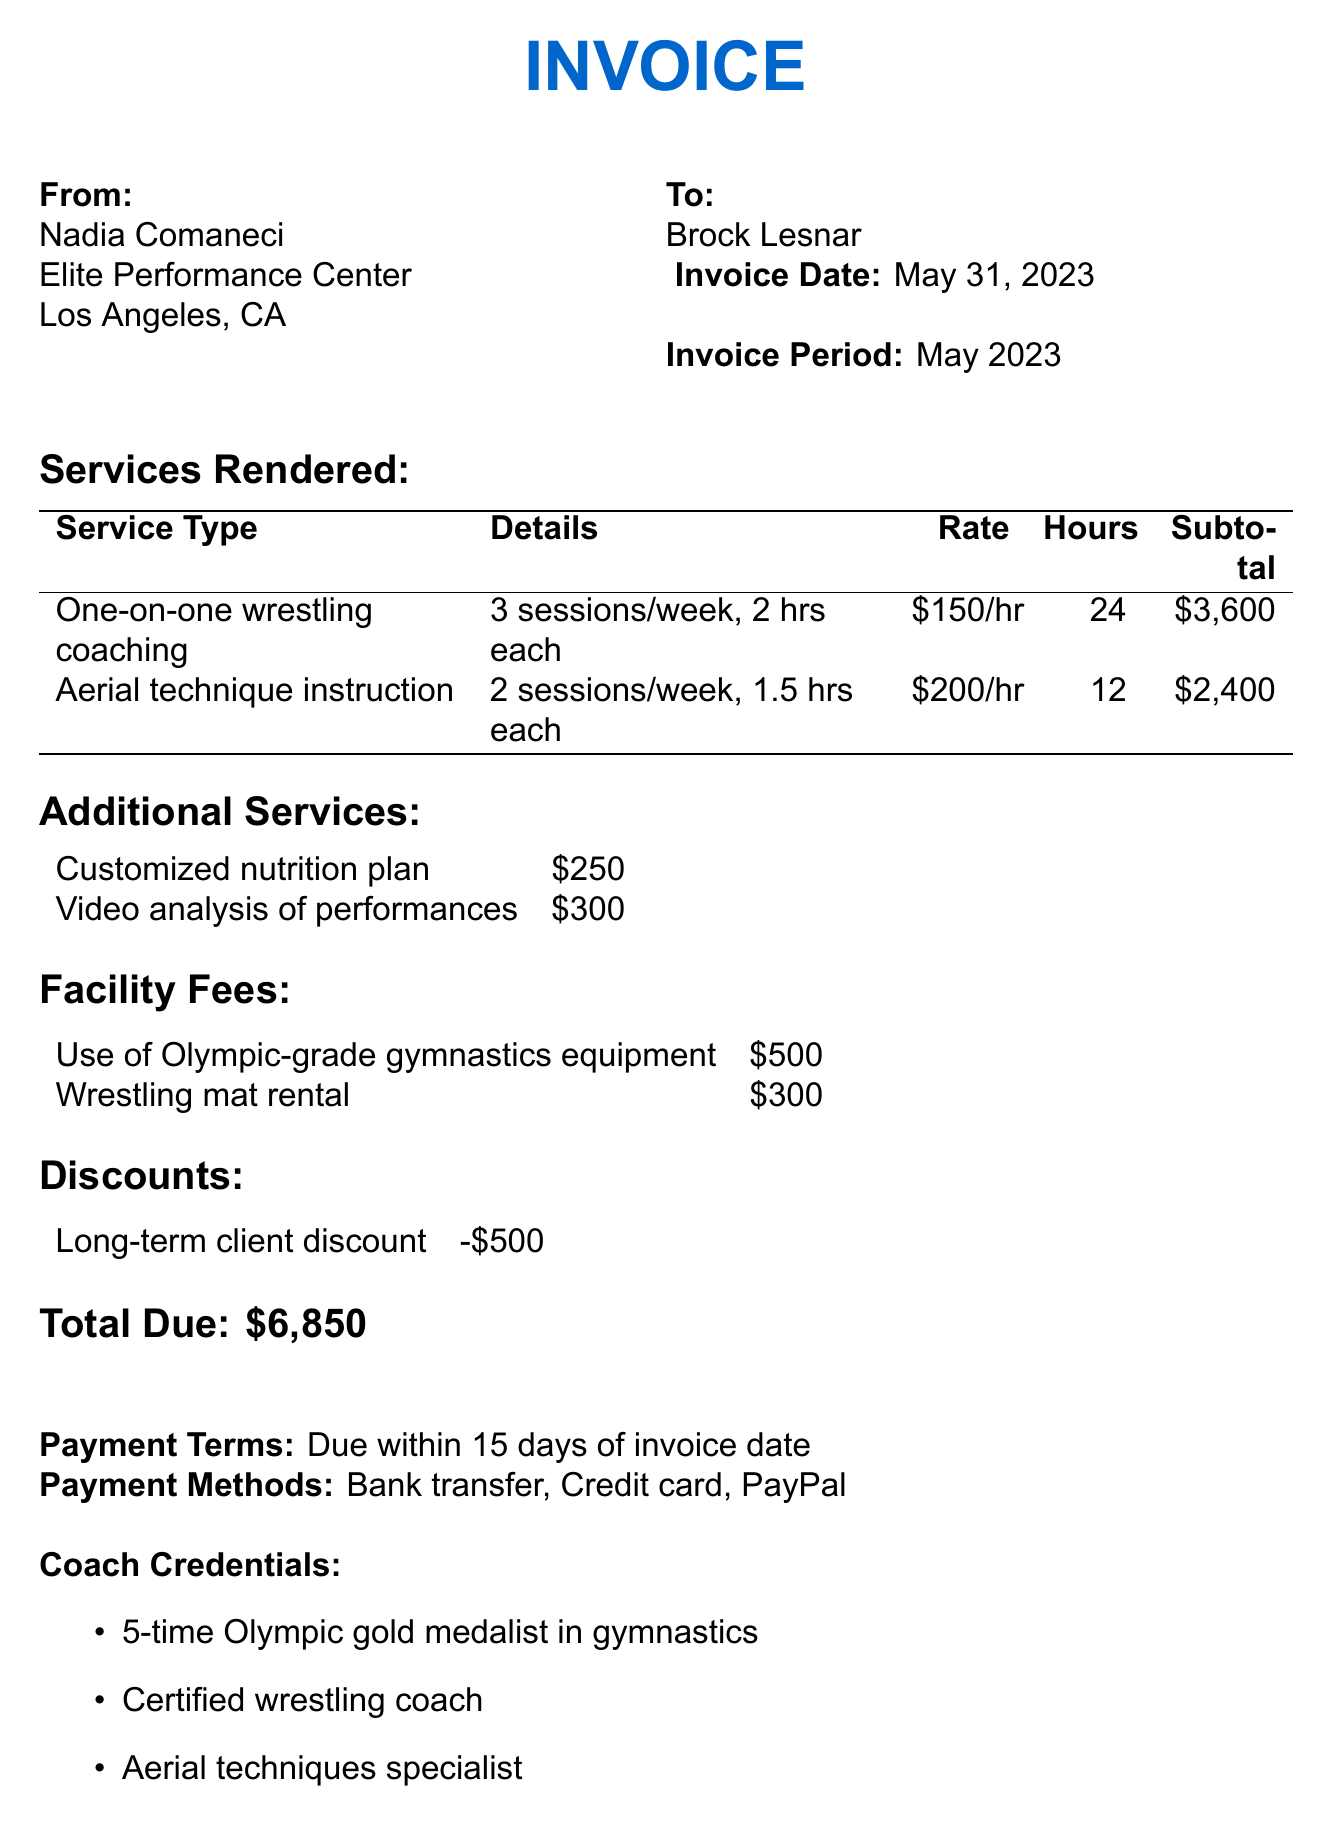What is the coach's name? The coach's name is listed in the document as the person issuing the invoice.
Answer: Nadia Comaneci How many one-on-one wrestling coaching sessions are provided per week? The document details the frequency of the wrestling coaching sessions per week.
Answer: 3 What is the total due amount for the services? The total due is provided at the end of the invoice after listing all services and fees.
Answer: 6,850 What is the rate per hour for aerial technique instruction? The hourly rate for aerial technique instruction is specified alongside the session details.
Answer: 200 What discount is offered to long-term clients? The document specifies the discount amount under the discounts section.
Answer: -500 How many total hours of one-on-one wrestling coaching are included? Total hours are calculated based on the number of sessions and duration per session mentioned in the invoice.
Answer: 24 What is the payment terms provided in the invoice? The payment terms are stated clearly in the document to inform the client of the timeline for payment.
Answer: Due within 15 days of invoice date What facility fee is associated with wrestling mat rental? The facility fee for the wrestling mat rental is stated clearly in the facility fees section of the invoice.
Answer: 300 What is the cancellation policy mentioned in the document? The cancellation policy outlines the notice required prior to cancellations and fees involved if not followed.
Answer: 24-hour notice required for cancellations, otherwise full session fee applies 